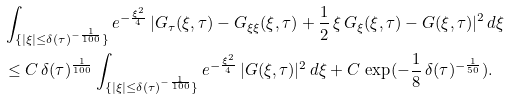<formula> <loc_0><loc_0><loc_500><loc_500>& \int _ { \{ | \xi | \leq \delta ( \tau ) ^ { - \frac { 1 } { 1 0 0 } } \} } e ^ { - \frac { \xi ^ { 2 } } { 4 } } \, | G _ { \tau } ( \xi , \tau ) - G _ { \xi \xi } ( \xi , \tau ) + \frac { 1 } { 2 } \, \xi \, G _ { \xi } ( \xi , \tau ) - G ( \xi , \tau ) | ^ { 2 } \, d \xi \\ & \leq C \, \delta ( \tau ) ^ { \frac { 1 } { 1 0 0 } } \int _ { \{ | \xi | \leq \delta ( \tau ) ^ { - \frac { 1 } { 1 0 0 } } \} } e ^ { - \frac { \xi ^ { 2 } } { 4 } } \, | G ( \xi , \tau ) | ^ { 2 } \, d \xi + C \, \exp ( - \frac { 1 } { 8 } \, \delta ( \tau ) ^ { - \frac { 1 } { 5 0 } } ) .</formula> 